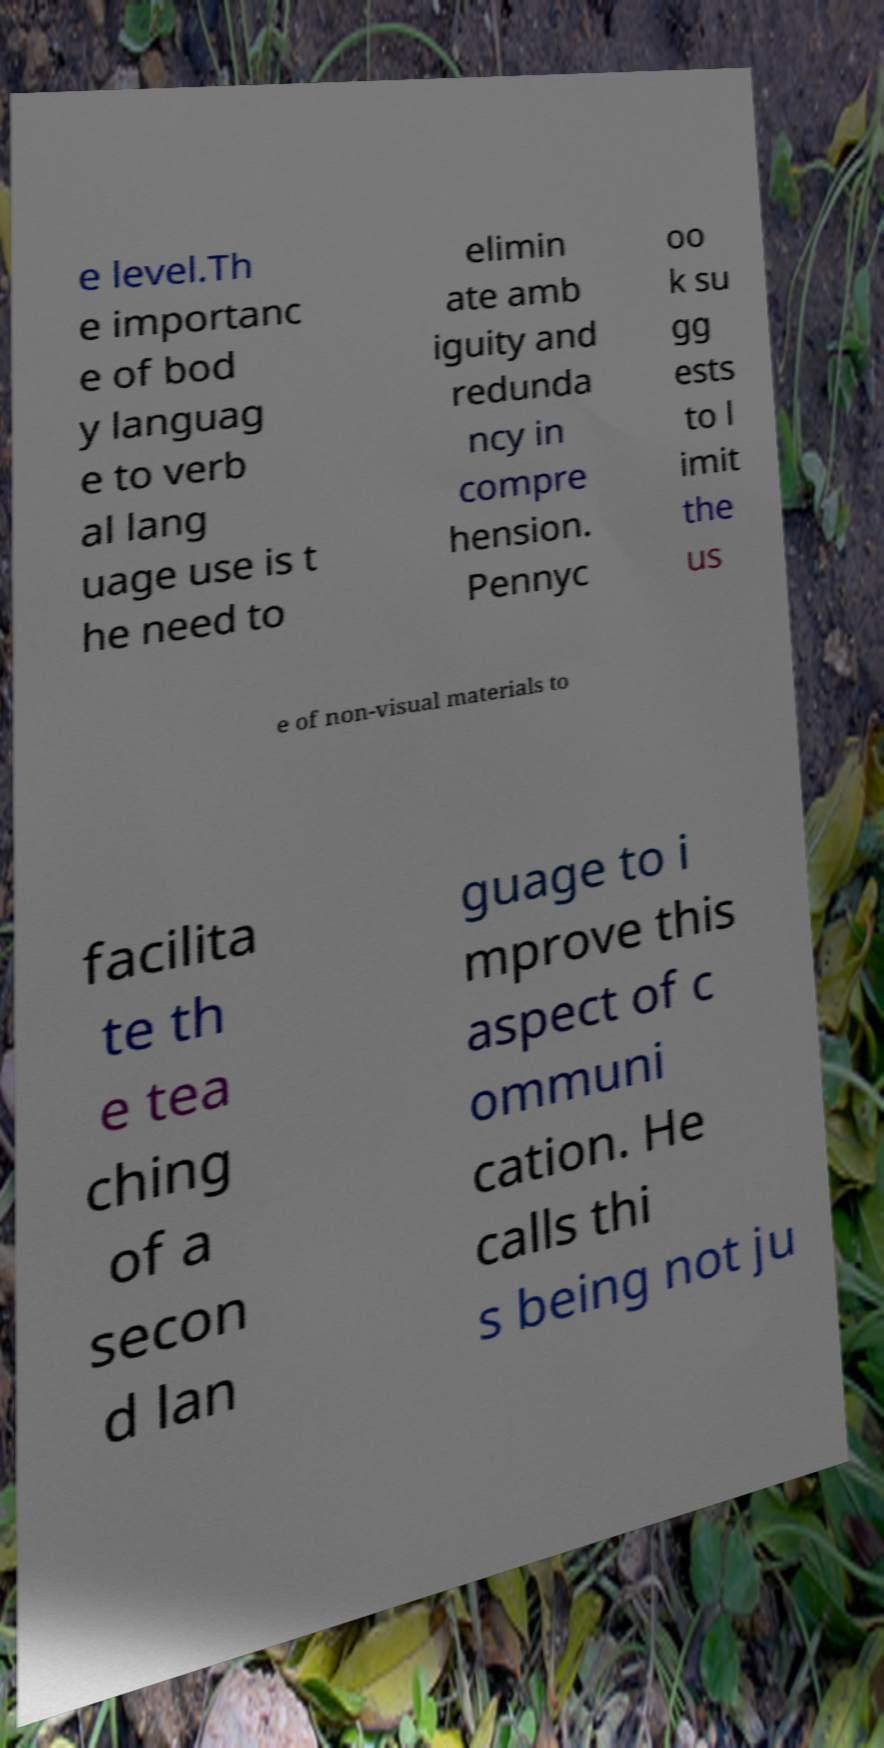Could you extract and type out the text from this image? e level.Th e importanc e of bod y languag e to verb al lang uage use is t he need to elimin ate amb iguity and redunda ncy in compre hension. Pennyc oo k su gg ests to l imit the us e of non-visual materials to facilita te th e tea ching of a secon d lan guage to i mprove this aspect of c ommuni cation. He calls thi s being not ju 